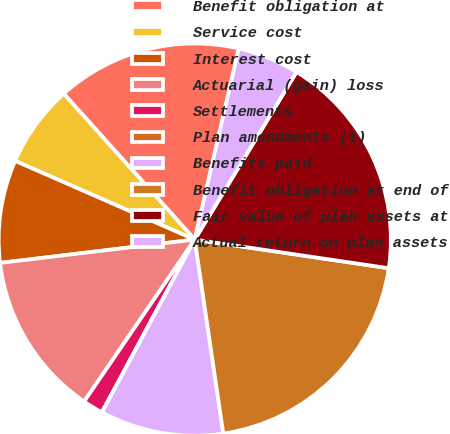Convert chart. <chart><loc_0><loc_0><loc_500><loc_500><pie_chart><fcel>Benefit obligation at<fcel>Service cost<fcel>Interest cost<fcel>Actuarial (gain) loss<fcel>Settlements<fcel>Plan amendments (1)<fcel>Benefits paid<fcel>Benefit obligation at end of<fcel>Fair value of plan assets at<fcel>Actual return on plan assets<nl><fcel>15.25%<fcel>6.78%<fcel>8.47%<fcel>13.56%<fcel>1.69%<fcel>0.0%<fcel>10.17%<fcel>20.34%<fcel>18.64%<fcel>5.08%<nl></chart> 